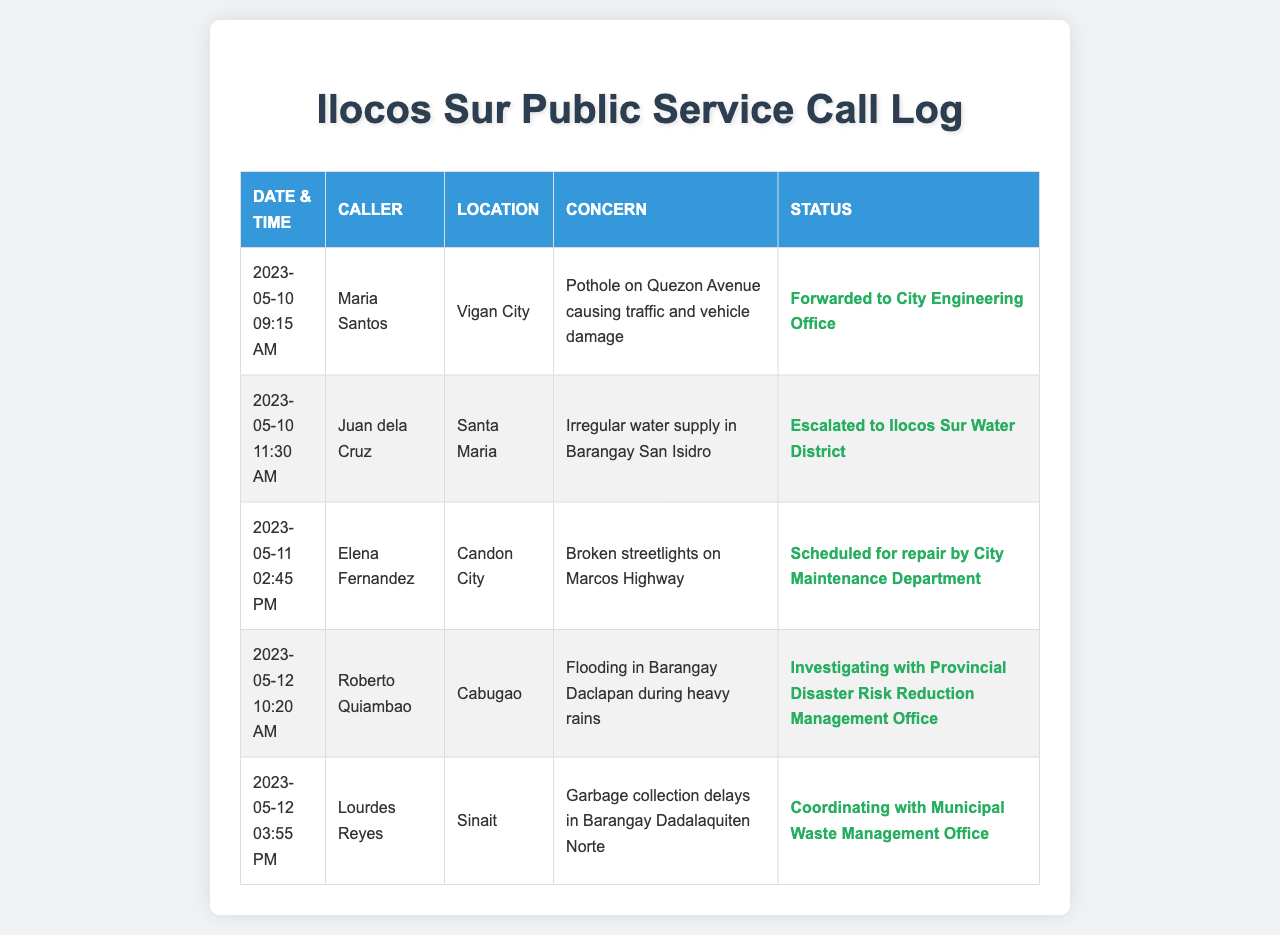What was the date and time of Maria Santos's call? The date and time can be found in the first row of the call log under "Date & Time".
Answer: 2023-05-10, 09:15 AM What concern did Juan dela Cruz report? The concern is listed in the "Concern" column for Juan dela Cruz’s record.
Answer: Irregular water supply in Barangay San Isidro Which location reported flooding during heavy rains? The location is mentioned in the "Location" column of the call log for Roberto Quiambao's entry.
Answer: Cabugao How many calls were regarding public service issues on May 12, 2023? The number of calls can be counted from the two records found on that date in the call log.
Answer: 2 What is the status of the concern reported by Elena Fernandez? The status is included in the same row as her call in the "Status" column.
Answer: Scheduled for repair by City Maintenance Department Who reported garbage collection delays? The caller's name can be found in the row that discusses garbage collection under the "Caller" column.
Answer: Lourdes Reyes What department is investigating the flooding issue in Barangay Daclapan? The department is mentioned in the status for Roberto Quiambao’s concern about flooding.
Answer: Provincial Disaster Risk Reduction Management Office Which concern was forwarded to the City Engineering Office? This can be found in the status of Maria Santos's call regarding the pothole.
Answer: Pothole on Quezon Avenue causing traffic and vehicle damage 